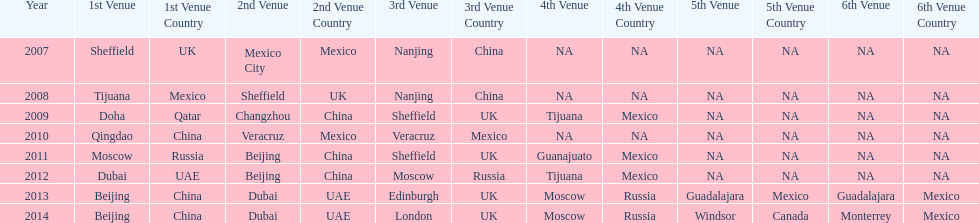Could you parse the entire table as a dict? {'header': ['Year', '1st Venue', '1st Venue Country', '2nd Venue', '2nd Venue Country', '3rd Venue', '3rd Venue Country', '4th Venue', '4th Venue Country', '5th Venue', '5th Venue Country', '6th Venue', '6th Venue Country'], 'rows': [['2007', 'Sheffield', 'UK', 'Mexico City', 'Mexico', 'Nanjing', 'China', 'NA', 'NA', 'NA', 'NA', 'NA', 'NA'], ['2008', 'Tijuana', 'Mexico', 'Sheffield', 'UK', 'Nanjing', 'China', 'NA', 'NA', 'NA', 'NA', 'NA', 'NA'], ['2009', 'Doha', 'Qatar', 'Changzhou', 'China', 'Sheffield', 'UK', 'Tijuana', 'Mexico', 'NA', 'NA', 'NA', 'NA'], ['2010', 'Qingdao', 'China', 'Veracruz', 'Mexico', 'Veracruz', 'Mexico', 'NA', 'NA', 'NA', 'NA', 'NA', 'NA'], ['2011', 'Moscow', 'Russia', 'Beijing', 'China', 'Sheffield', 'UK', 'Guanajuato', 'Mexico', 'NA', 'NA', 'NA', 'NA'], ['2012', 'Dubai', 'UAE', 'Beijing', 'China', 'Moscow', 'Russia', 'Tijuana', 'Mexico', 'NA', 'NA', 'NA', 'NA'], ['2013', 'Beijing', 'China', 'Dubai', 'UAE', 'Edinburgh', 'UK', 'Moscow', 'Russia', 'Guadalajara', 'Mexico', 'Guadalajara', 'Mexico'], ['2014', 'Beijing', 'China', 'Dubai', 'UAE', 'London', 'UK', 'Moscow', 'Russia', 'Windsor', 'Canada', 'Monterrey', 'Mexico']]} Which year is previous to 2011 2010. 